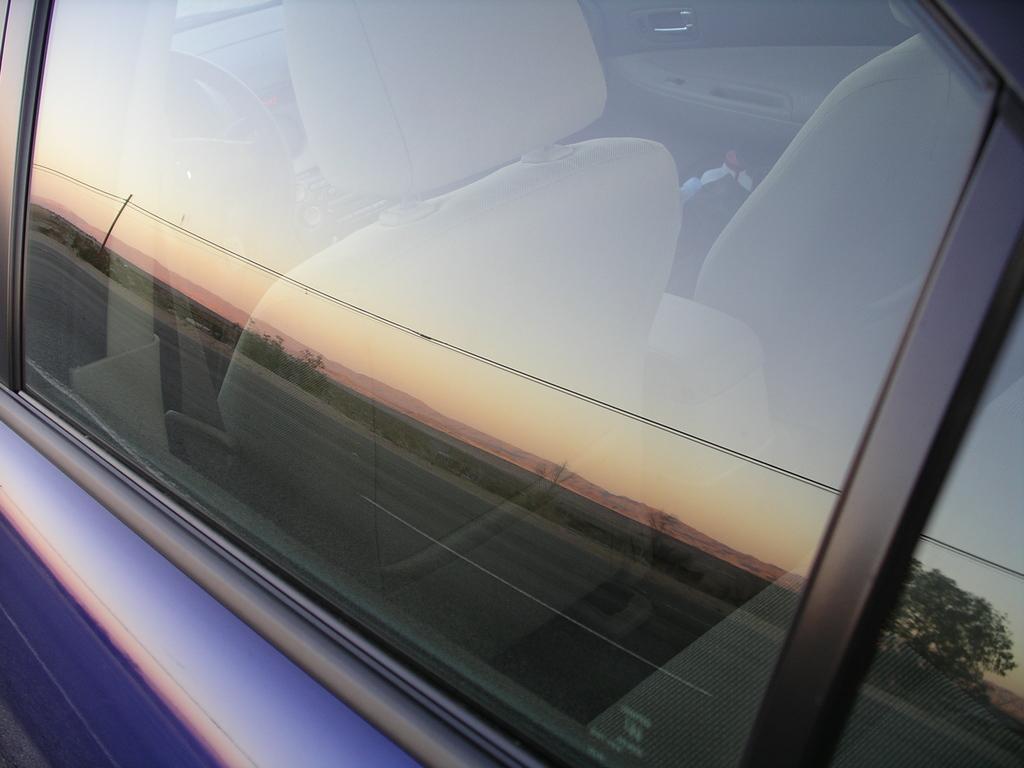Please provide a concise description of this image. The picture consists of a car, we can see the seats and steering of the car. 